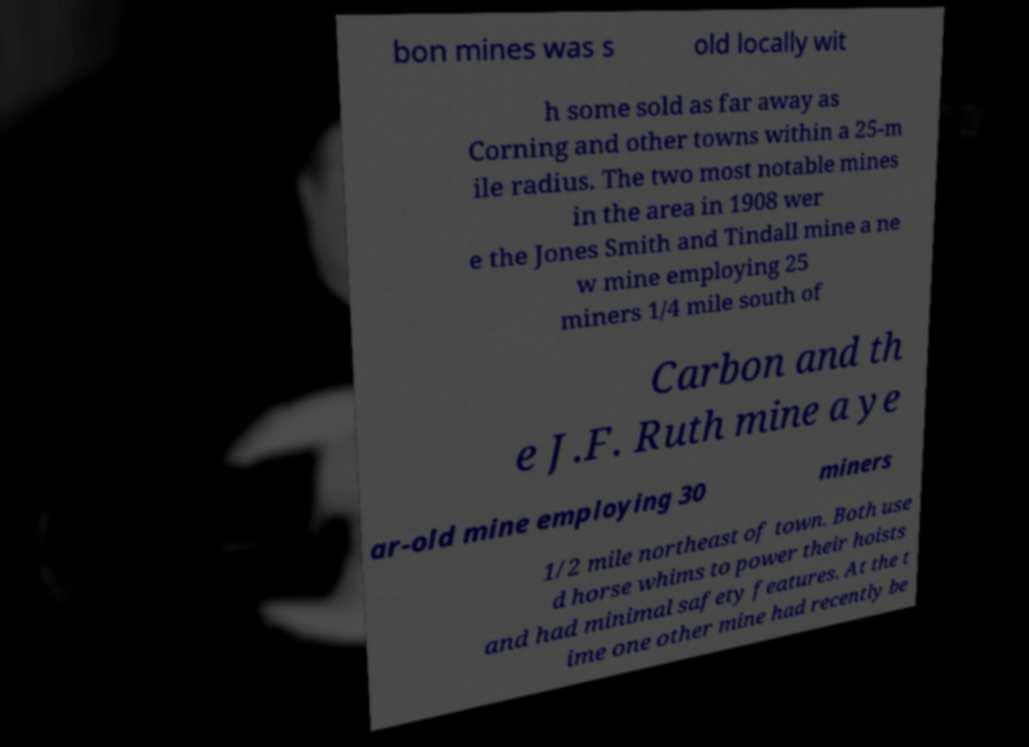There's text embedded in this image that I need extracted. Can you transcribe it verbatim? bon mines was s old locally wit h some sold as far away as Corning and other towns within a 25-m ile radius. The two most notable mines in the area in 1908 wer e the Jones Smith and Tindall mine a ne w mine employing 25 miners 1/4 mile south of Carbon and th e J.F. Ruth mine a ye ar-old mine employing 30 miners 1/2 mile northeast of town. Both use d horse whims to power their hoists and had minimal safety features. At the t ime one other mine had recently be 